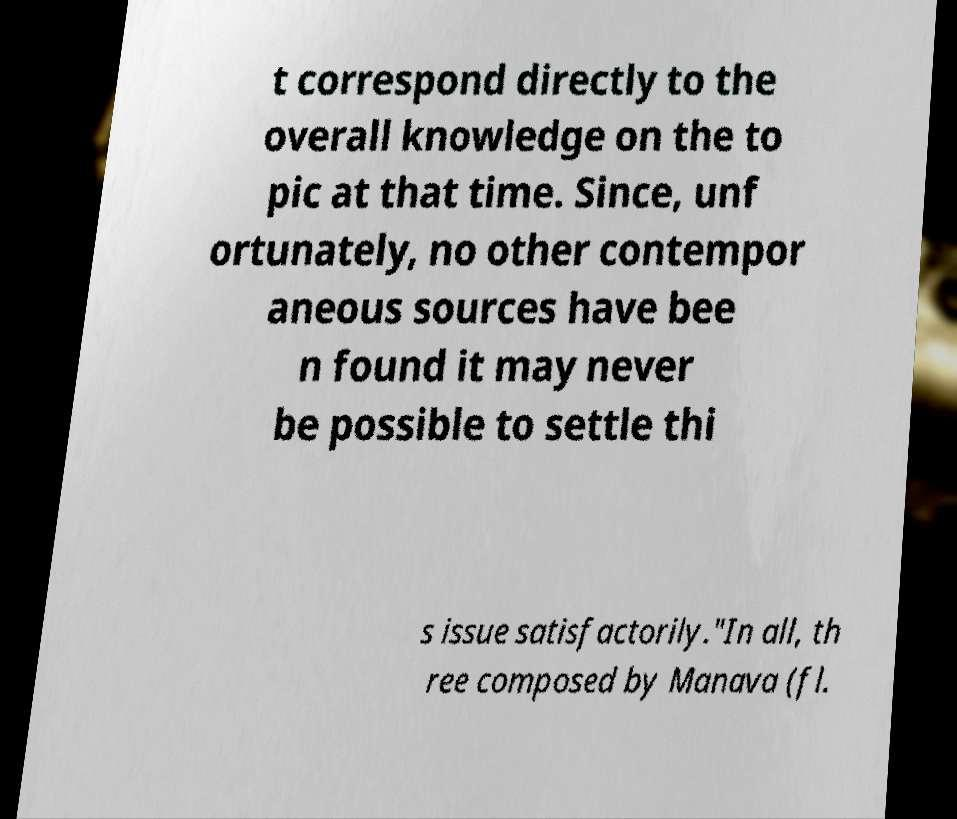What messages or text are displayed in this image? I need them in a readable, typed format. t correspond directly to the overall knowledge on the to pic at that time. Since, unf ortunately, no other contempor aneous sources have bee n found it may never be possible to settle thi s issue satisfactorily."In all, th ree composed by Manava (fl. 